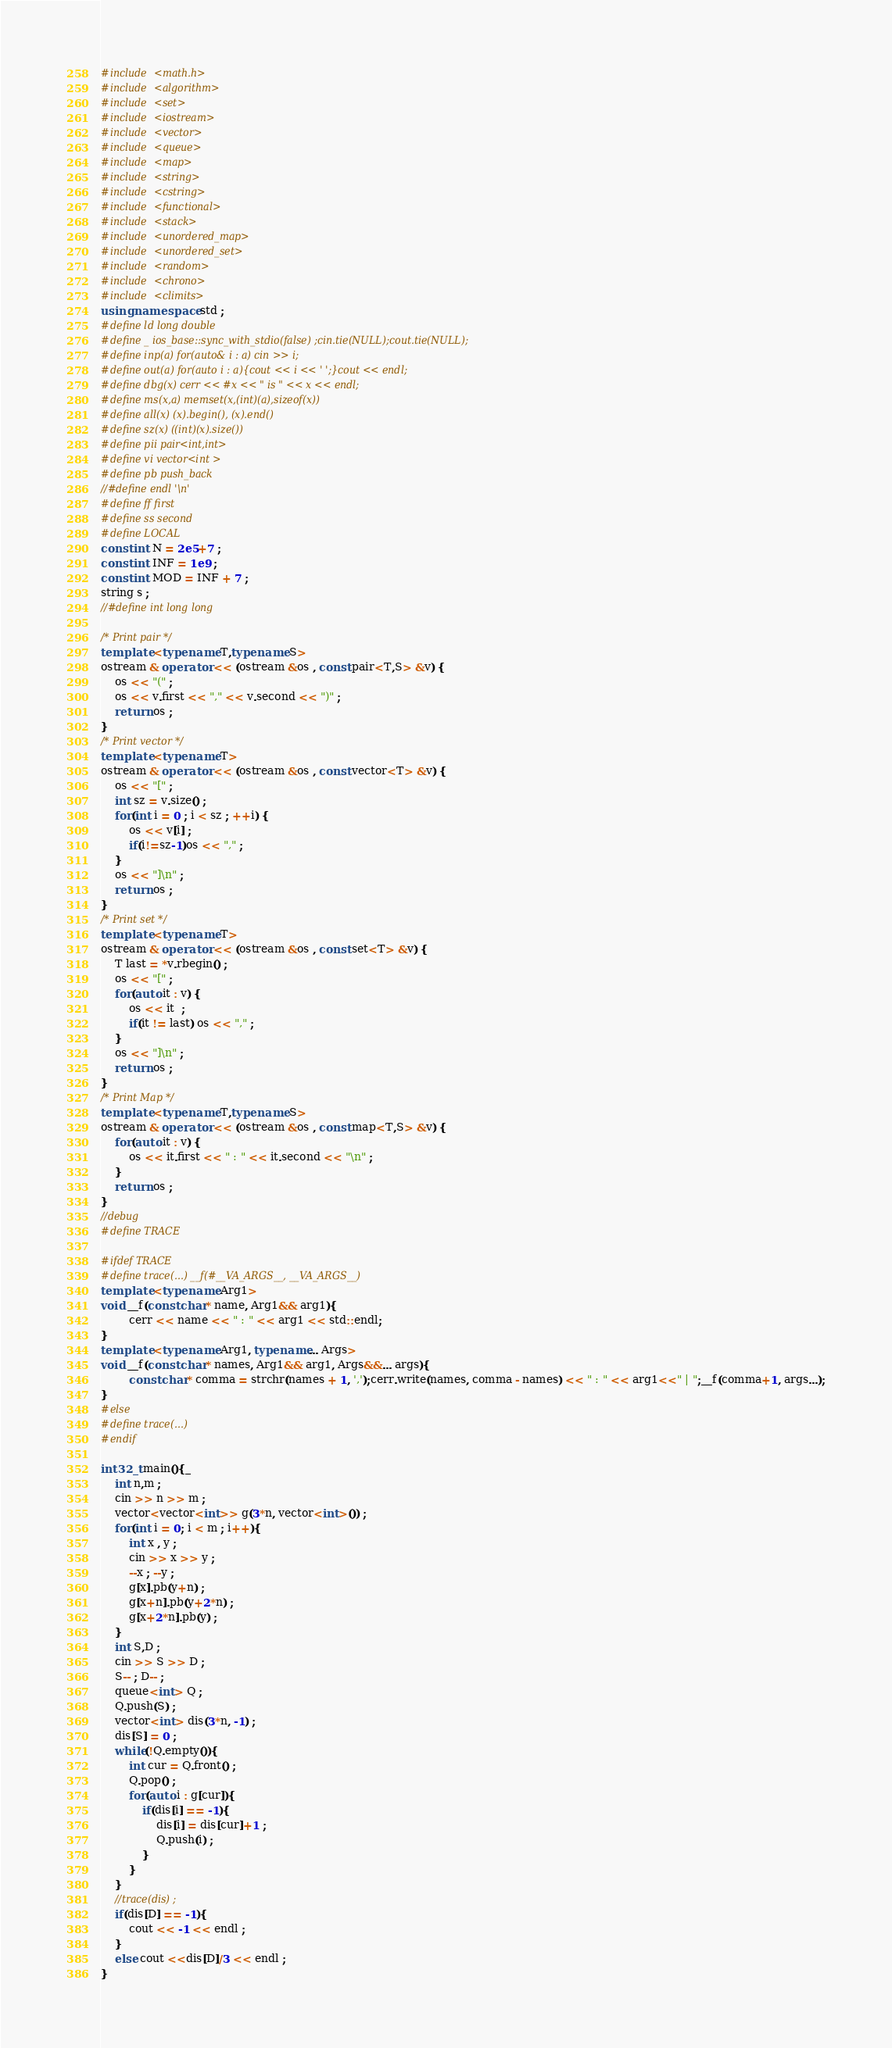Convert code to text. <code><loc_0><loc_0><loc_500><loc_500><_C++_>#include <math.h>
#include <algorithm>
#include <set>
#include <iostream>
#include <vector>
#include <queue>
#include <map>
#include <string>
#include <cstring>
#include <functional>
#include <stack>
#include <unordered_map>
#include <unordered_set>
#include <random>
#include <chrono>
#include <climits>
using namespace std ;
#define ld long double
#define _ ios_base::sync_with_stdio(false) ;cin.tie(NULL);cout.tie(NULL);
#define inp(a) for(auto& i : a) cin >> i;
#define out(a) for(auto i : a){cout << i << ' ';}cout << endl;
#define dbg(x) cerr << #x << " is " << x << endl;
#define ms(x,a) memset(x,(int)(a),sizeof(x))
#define all(x) (x).begin(), (x).end()
#define sz(x) ((int)(x).size())
#define pii pair<int,int>
#define vi vector<int >
#define pb push_back
//#define endl '\n'
#define ff first
#define ss second
#define LOCAL
const int N = 2e5+7 ;
const int INF = 1e9 ;
const int MOD = INF + 7 ;
string s ;
//#define int long long

/* Print pair */
template <typename T,typename S>
ostream & operator << (ostream &os , const pair<T,S> &v) {
    os << "(" ;
    os << v.first << "," << v.second << ")" ;
    return os ;
}
/* Print vector */
template <typename T>
ostream & operator << (ostream &os , const vector<T> &v) {
    os << "[" ;
    int sz = v.size() ;
    for(int i = 0 ; i < sz ; ++i) {
        os << v[i] ;
        if(i!=sz-1)os << "," ;
    }
    os << "]\n" ;
    return os ;
}
/* Print set */
template <typename T>
ostream & operator << (ostream &os , const set<T> &v) {
    T last = *v.rbegin() ;
    os << "[" ;
    for(auto it : v) {
        os << it  ;
        if(it != last) os << "," ;
    }
    os << "]\n" ;
    return os ;
}
/* Print Map */
template <typename T,typename S>
ostream & operator << (ostream &os , const map<T,S> &v) {
    for(auto it : v) {
        os << it.first << " : " << it.second << "\n" ;
    }
    return os ;
}
//debug
#define TRACE

#ifdef TRACE
#define trace(...) __f(#__VA_ARGS__, __VA_ARGS__)
template <typename Arg1>
void __f(const char* name, Arg1&& arg1){
		cerr << name << " : " << arg1 << std::endl;
}
template <typename Arg1, typename... Args>
void __f(const char* names, Arg1&& arg1, Args&&... args){
		const char* comma = strchr(names + 1, ',');cerr.write(names, comma - names) << " : " << arg1<<" | ";__f(comma+1, args...);
}
#else
#define trace(...)
#endif

int32_t main(){_
	int n,m ;
	cin >> n >> m ;
	vector<vector<int>> g(3*n, vector<int>()) ;
	for(int i = 0; i < m ; i++){
		int x , y ;
		cin >> x >> y ;
		--x ; --y ;
		g[x].pb(y+n) ;
		g[x+n].pb(y+2*n) ;
		g[x+2*n].pb(y) ;
	}
	int S,D ;
	cin >> S >> D ;
	S-- ; D-- ;
	queue<int> Q ;
	Q.push(S) ;
	vector<int> dis(3*n, -1) ;
	dis[S] = 0 ;
	while(!Q.empty()){
		int cur = Q.front() ;
		Q.pop() ;
		for(auto i : g[cur]){
			if(dis[i] == -1){
				dis[i] = dis[cur]+1 ;
				Q.push(i) ;
			}
		}
	}
	//trace(dis) ;
	if(dis[D] == -1){
		cout << -1 << endl ;
	}
	else cout <<dis[D]/3 << endl ;
}
</code> 